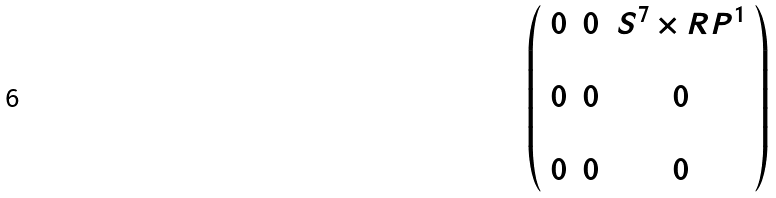<formula> <loc_0><loc_0><loc_500><loc_500>\left ( \begin{array} { c c c } 0 & 0 & S ^ { 7 } \times { R } P ^ { 1 } \\ & & \\ 0 & 0 & 0 \\ & & \\ 0 & 0 & 0 \end{array} \right )</formula> 